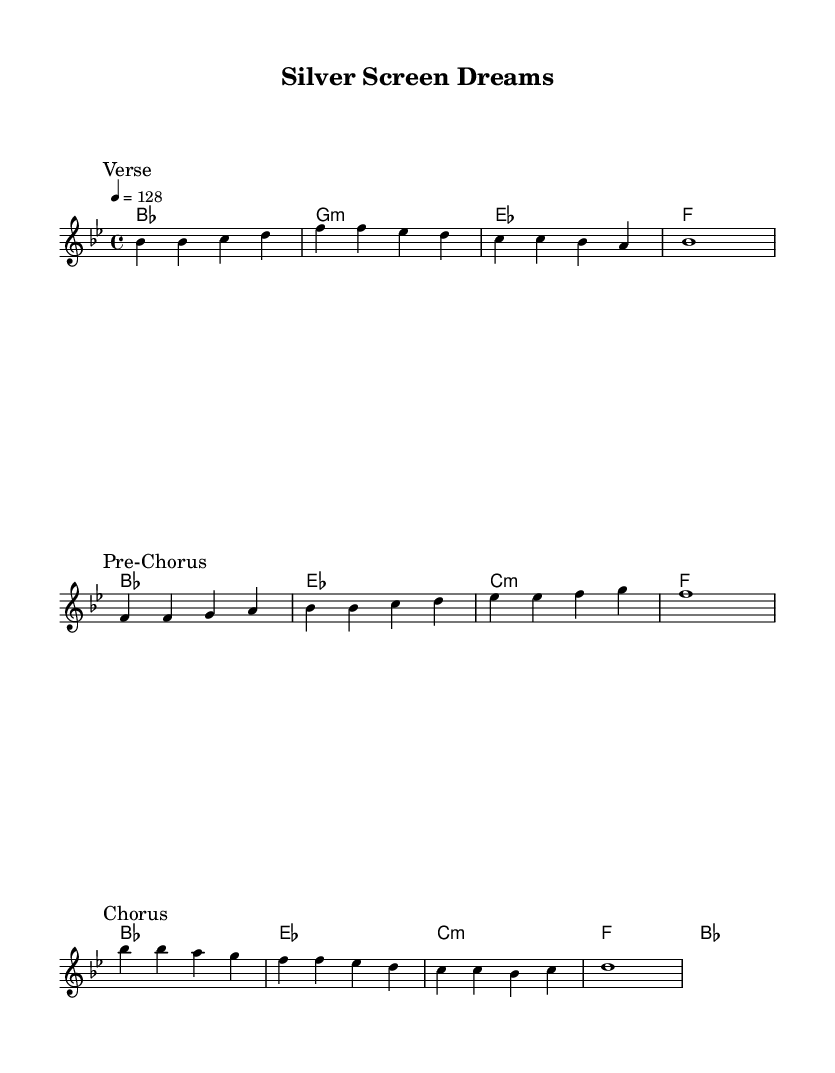What is the key signature of this music? The key signature has two flats, indicating that it is in B flat major.
Answer: B flat major What is the time signature of this piece? The time signature is indicated as four beats per measure, represented by the notation 4/4.
Answer: 4/4 What is the tempo marking of the piece? The tempo marking is indicated as quarter note equals 128 beats per minute, showing the speed of the music.
Answer: 128 How many sections does the music consist of? The music has three distinct sections labeled as "Verse," "Pre-Chorus," and "Chorus."
Answer: Three What is the first chord in the harmony section? The first chord in the harmony section is B flat major, as it is the initial chord listed in the chord changes.
Answer: B flat major Which section contains the longest note value? The "Chorus" section consists of a whole note on the last beat, indicating the longest note duration in the piece.
Answer: Chorus What is the last chord of the piece? The last chord in the harmony section is B flat major, as it appears at the end of the chord progression.
Answer: B flat major 